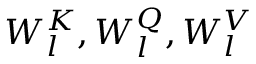<formula> <loc_0><loc_0><loc_500><loc_500>W _ { l } ^ { K } , W _ { l } ^ { Q } , W _ { l } ^ { V }</formula> 